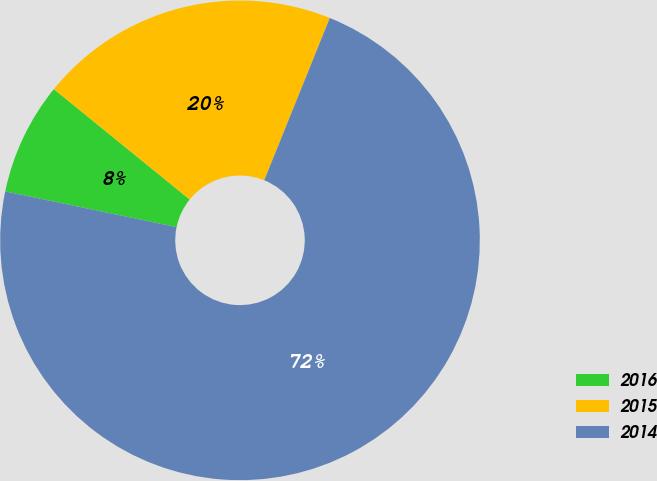Convert chart. <chart><loc_0><loc_0><loc_500><loc_500><pie_chart><fcel>2016<fcel>2015<fcel>2014<nl><fcel>7.59%<fcel>20.25%<fcel>72.15%<nl></chart> 